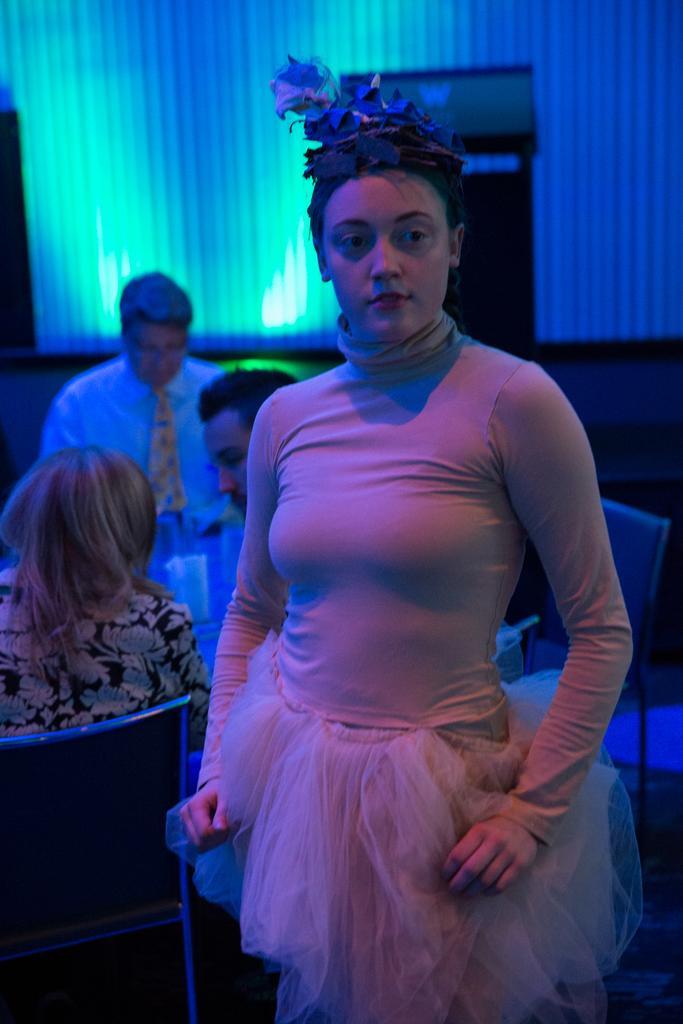Describe this image in one or two sentences. In this image we can see four persons, among them, one person is standing and three persons are sitting on the chairs, in front of them, we can see a table, on the table, we can see the glasses, there is a podium and in the background, it looks like a curtain. 